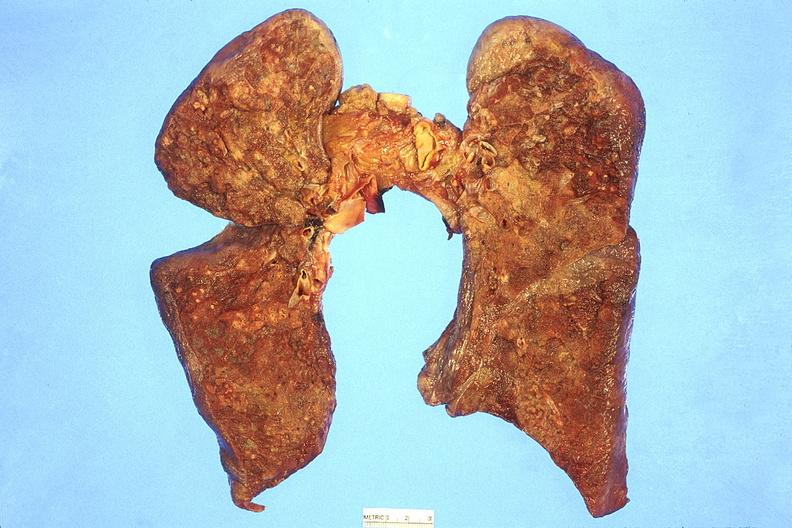does this image show lung, abscesses?
Answer the question using a single word or phrase. Yes 